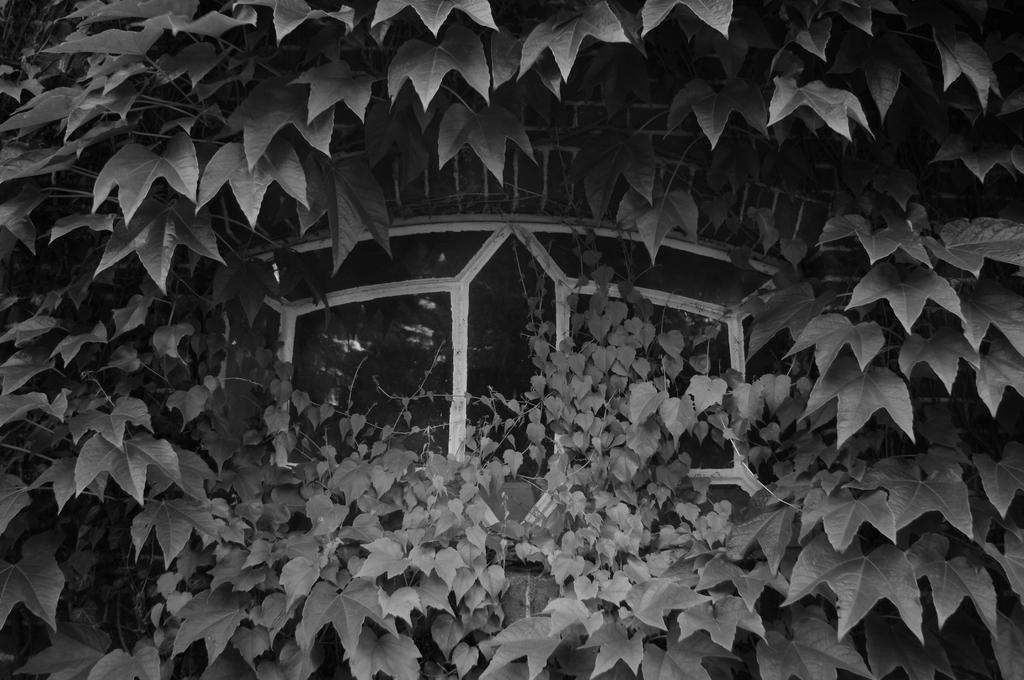What is the color scheme of the image? The image is black and white. Where was the image taken? The image was taken outdoors. What type of plant can be seen in the image? There is a creeper with many leaves in the image. What architectural feature is present in the image? There is a window in the middle of the image. What type of rub is being used to clean the window in the image? There is no rub visible in the image, and the window appears to be clean. 